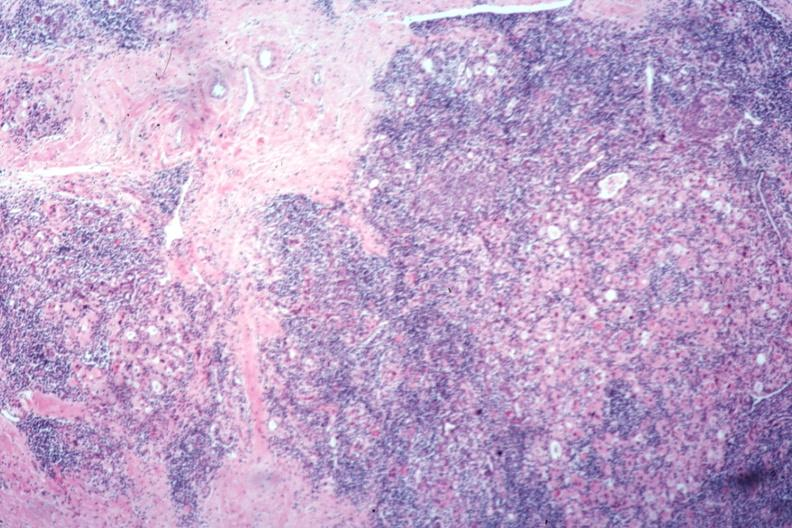s autoimmune thyroiditis present?
Answer the question using a single word or phrase. Yes 